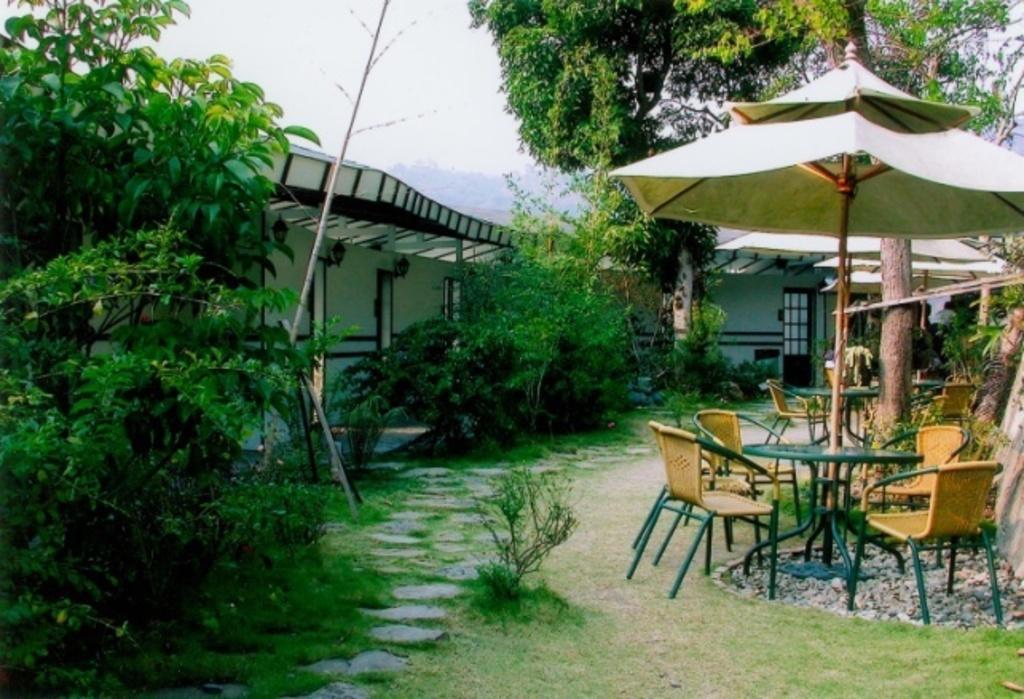Please provide a concise description of this image. This is an outside view. On the right side there is a table and few chairs under the umbrella. On the left side there are some trees. In the background there is a house. In the bottom, I can see the grass on the ground. At the top of the image I can see the sky. 